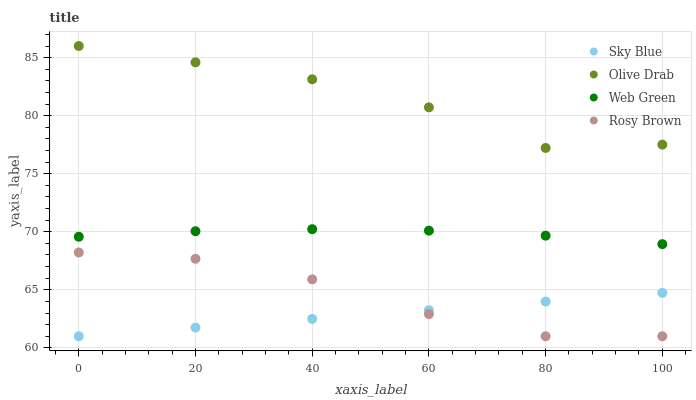Does Sky Blue have the minimum area under the curve?
Answer yes or no. Yes. Does Olive Drab have the maximum area under the curve?
Answer yes or no. Yes. Does Rosy Brown have the minimum area under the curve?
Answer yes or no. No. Does Rosy Brown have the maximum area under the curve?
Answer yes or no. No. Is Sky Blue the smoothest?
Answer yes or no. Yes. Is Olive Drab the roughest?
Answer yes or no. Yes. Is Rosy Brown the smoothest?
Answer yes or no. No. Is Rosy Brown the roughest?
Answer yes or no. No. Does Sky Blue have the lowest value?
Answer yes or no. Yes. Does Web Green have the lowest value?
Answer yes or no. No. Does Olive Drab have the highest value?
Answer yes or no. Yes. Does Rosy Brown have the highest value?
Answer yes or no. No. Is Sky Blue less than Olive Drab?
Answer yes or no. Yes. Is Web Green greater than Rosy Brown?
Answer yes or no. Yes. Does Rosy Brown intersect Sky Blue?
Answer yes or no. Yes. Is Rosy Brown less than Sky Blue?
Answer yes or no. No. Is Rosy Brown greater than Sky Blue?
Answer yes or no. No. Does Sky Blue intersect Olive Drab?
Answer yes or no. No. 